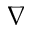Convert formula to latex. <formula><loc_0><loc_0><loc_500><loc_500>\nabla</formula> 